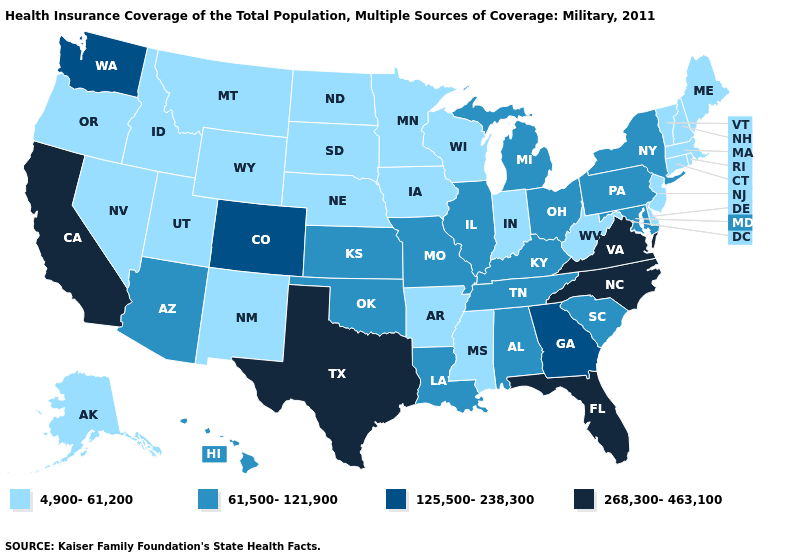What is the highest value in states that border North Dakota?
Short answer required. 4,900-61,200. How many symbols are there in the legend?
Write a very short answer. 4. Name the states that have a value in the range 61,500-121,900?
Short answer required. Alabama, Arizona, Hawaii, Illinois, Kansas, Kentucky, Louisiana, Maryland, Michigan, Missouri, New York, Ohio, Oklahoma, Pennsylvania, South Carolina, Tennessee. Does Iowa have a lower value than Colorado?
Be succinct. Yes. What is the value of Alaska?
Short answer required. 4,900-61,200. Name the states that have a value in the range 4,900-61,200?
Concise answer only. Alaska, Arkansas, Connecticut, Delaware, Idaho, Indiana, Iowa, Maine, Massachusetts, Minnesota, Mississippi, Montana, Nebraska, Nevada, New Hampshire, New Jersey, New Mexico, North Dakota, Oregon, Rhode Island, South Dakota, Utah, Vermont, West Virginia, Wisconsin, Wyoming. Name the states that have a value in the range 4,900-61,200?
Quick response, please. Alaska, Arkansas, Connecticut, Delaware, Idaho, Indiana, Iowa, Maine, Massachusetts, Minnesota, Mississippi, Montana, Nebraska, Nevada, New Hampshire, New Jersey, New Mexico, North Dakota, Oregon, Rhode Island, South Dakota, Utah, Vermont, West Virginia, Wisconsin, Wyoming. What is the lowest value in the MidWest?
Quick response, please. 4,900-61,200. Among the states that border Michigan , does Ohio have the highest value?
Short answer required. Yes. How many symbols are there in the legend?
Keep it brief. 4. What is the value of Minnesota?
Be succinct. 4,900-61,200. What is the value of Illinois?
Answer briefly. 61,500-121,900. What is the highest value in the USA?
Concise answer only. 268,300-463,100. Does Massachusetts have the lowest value in the USA?
Keep it brief. Yes. Does the first symbol in the legend represent the smallest category?
Write a very short answer. Yes. 